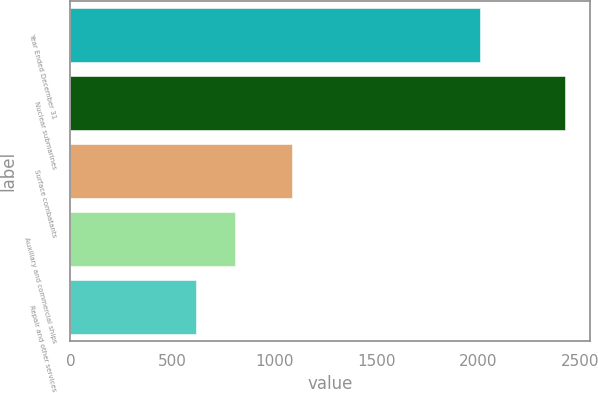Convert chart to OTSL. <chart><loc_0><loc_0><loc_500><loc_500><bar_chart><fcel>Year Ended December 31<fcel>Nuclear submarines<fcel>Surface combatants<fcel>Auxiliary and commercial ships<fcel>Repair and other services<nl><fcel>2006<fcel>2427<fcel>1088<fcel>807<fcel>618<nl></chart> 